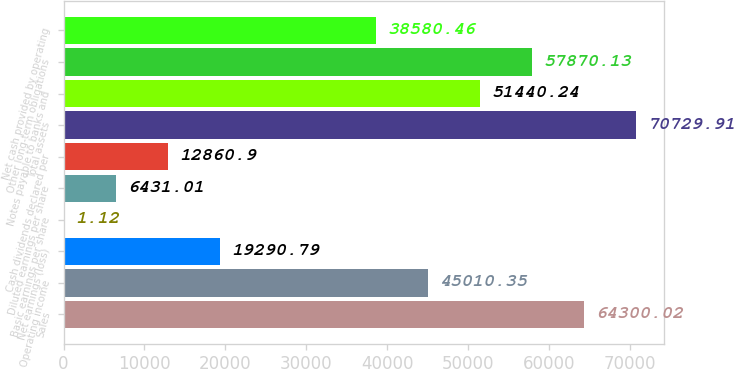Convert chart to OTSL. <chart><loc_0><loc_0><loc_500><loc_500><bar_chart><fcel>Sales<fcel>Operating income<fcel>Net earnings (loss)<fcel>Basic earnings per share<fcel>Diluted earnings per share<fcel>Cash dividends declared per<fcel>Total assets<fcel>Notes payable to banks and<fcel>Other long-term obligations<fcel>Net cash provided by operating<nl><fcel>64300<fcel>45010.3<fcel>19290.8<fcel>1.12<fcel>6431.01<fcel>12860.9<fcel>70729.9<fcel>51440.2<fcel>57870.1<fcel>38580.5<nl></chart> 